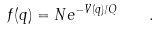<formula> <loc_0><loc_0><loc_500><loc_500>f ( { q } ) = N e ^ { - V ( { q } ) / Q } \quad .</formula> 